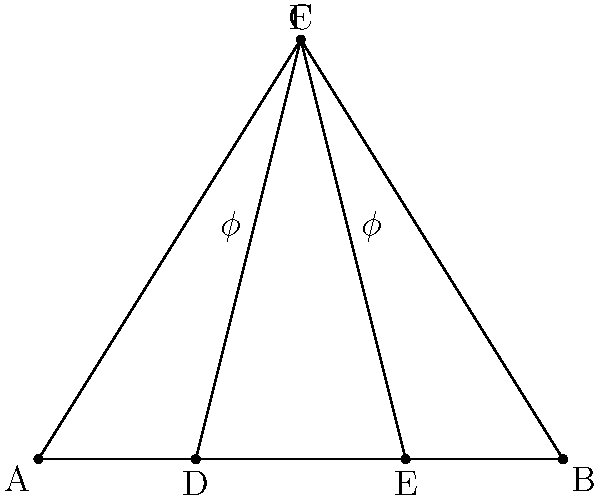In a Gothic arch design, the ratio of the width of the arch to its height is often related to the golden ratio ($\phi$). If the base of the arch (AB) is 10 meters wide, and the height (CF) is determined by the golden ratio such that $\frac{CF}{AC} = \phi$, calculate the exact height of the arch in meters. Round your answer to two decimal places. Let's approach this step-by-step:

1) The golden ratio $\phi$ is defined as $\phi = \frac{1 + \sqrt{5}}{2} \approx 1.618033988749895$

2) We know that $AB = 10$ meters and $AC = \frac{AB}{2} = 5$ meters

3) The relationship given is $\frac{CF}{AC} = \phi$

4) We can rearrange this to find CF:
   $CF = AC \cdot \phi$

5) Substituting the values:
   $CF = 5 \cdot \frac{1 + \sqrt{5}}{2}$

6) Simplifying:
   $CF = \frac{5 + 5\sqrt{5}}{2}$

7) To get a decimal approximation:
   $CF \approx 8.090169943749475$

8) Rounding to two decimal places:
   $CF \approx 8.09$ meters

Therefore, the height of the arch is approximately 8.09 meters.
Answer: 8.09 meters 